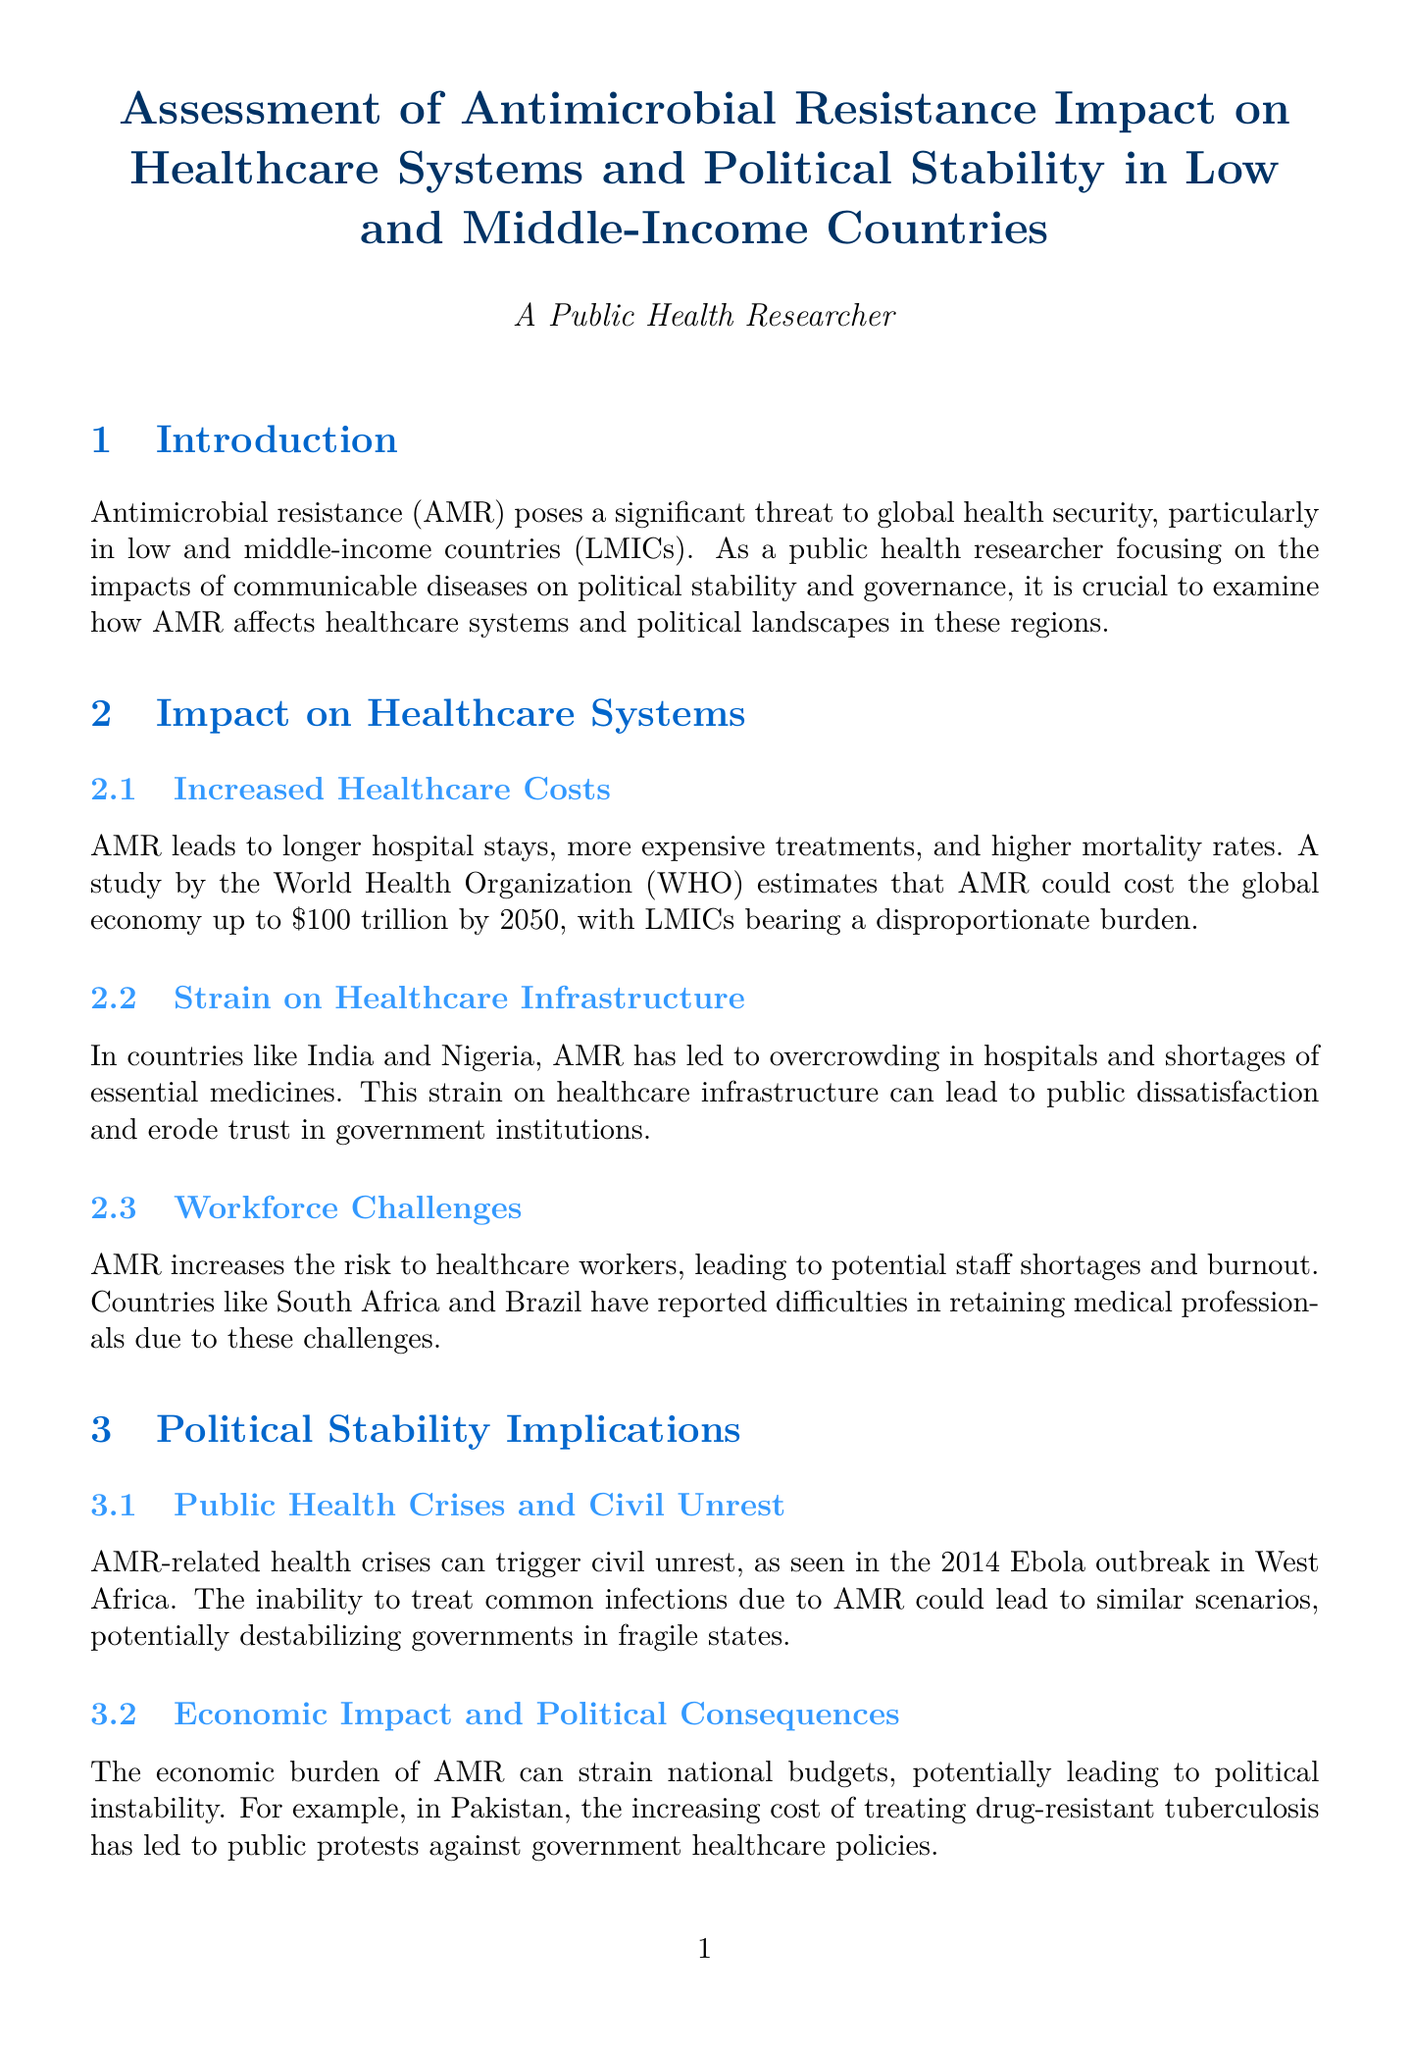What is the title of the report? The title of the report summarizes the focus on antimicrobial resistance and its impact on healthcare systems and political stability in LMICs.
Answer: Assessment of Antimicrobial Resistance Impact on Healthcare Systems and Political Stability in Low and Middle-Income Countries What year does the World Health Organization report mention regarding AMR costs? The document references a future projection from the World Health Organization that estimates costs related to AMR up to the year 2050.
Answer: 2050 Which countries are highlighted for their overcrowded hospitals due to AMR? The report specifically names India and Nigeria in the context of overcrowding in hospitals caused by AMR.
Answer: India and Nigeria What health crisis was referenced in the context of civil unrest? The document connects AMR-related health crises to the civil unrest triggered during a specific outbreak that occurred in West Africa.
Answer: 2014 Ebola outbreak What approach did Thailand implement to combat AMR? The document discusses a specific strategy employed by Thailand that emphasizes multidisciplinary collaboration to address AMR.
Answer: One Health approach What is one of the policy recommendations regarding antibiotic use? The report provides suggestions on regulations pertaining to antibiotic usage, highlighting the importance of control measures in healthcare.
Answer: Implementing stricter regulations on antibiotic use In which section of the document can you find information about AMR's impact on healthcare infrastructure? The relevant information about AMR's effect on healthcare infrastructure is contained within the designated section focusing on healthcare system impacts.
Answer: Impact on Healthcare Systems What is one expected economic consequence of AMR mentioned in the document? The document indicates that the rising economic burden from AMR can potentially influence national budgets, leading to adverse political outcomes.
Answer: Political instability 